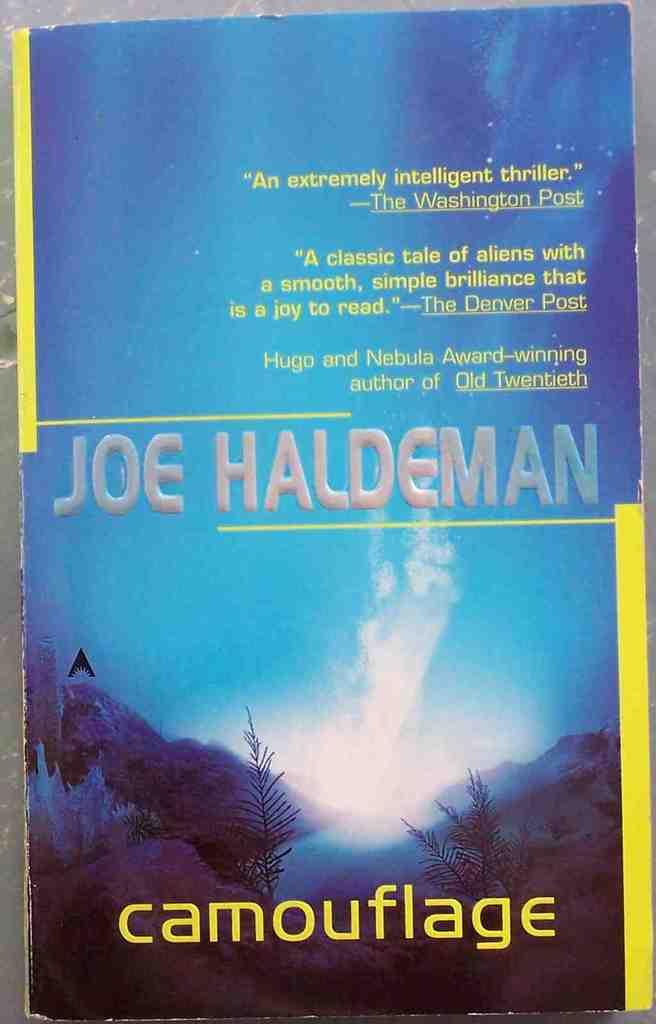Provide a one-sentence caption for the provided image. A book by Joe Haldeman titled Camouflage, in the color blue. 